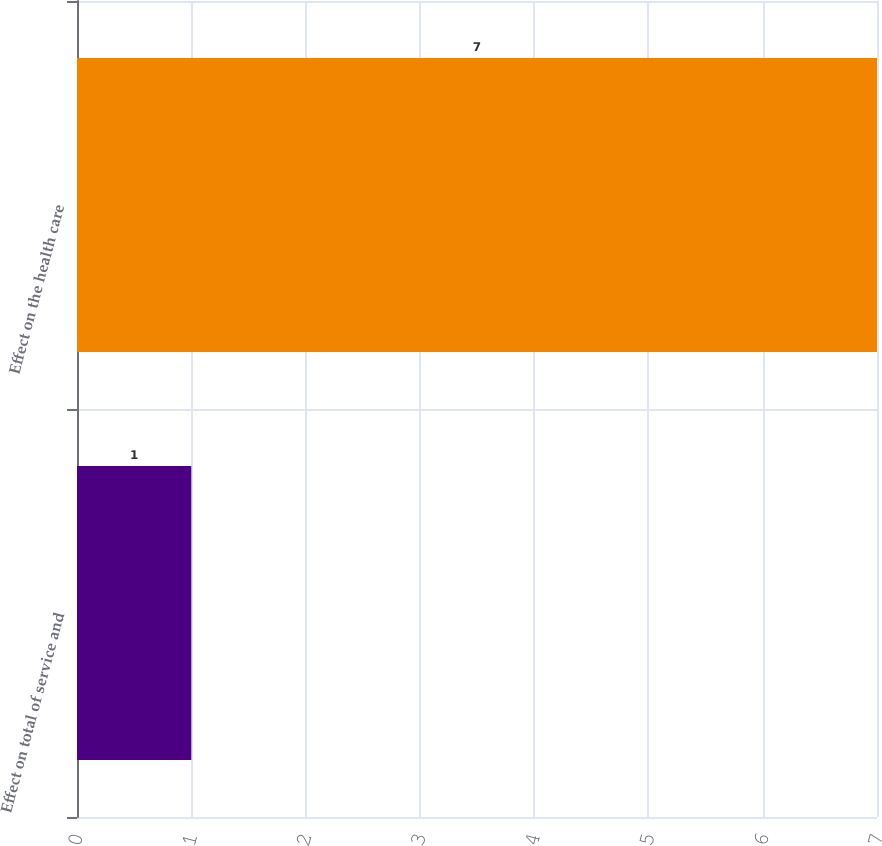Convert chart. <chart><loc_0><loc_0><loc_500><loc_500><bar_chart><fcel>Effect on total of service and<fcel>Effect on the health care<nl><fcel>1<fcel>7<nl></chart> 